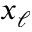<formula> <loc_0><loc_0><loc_500><loc_500>x _ { \ell }</formula> 